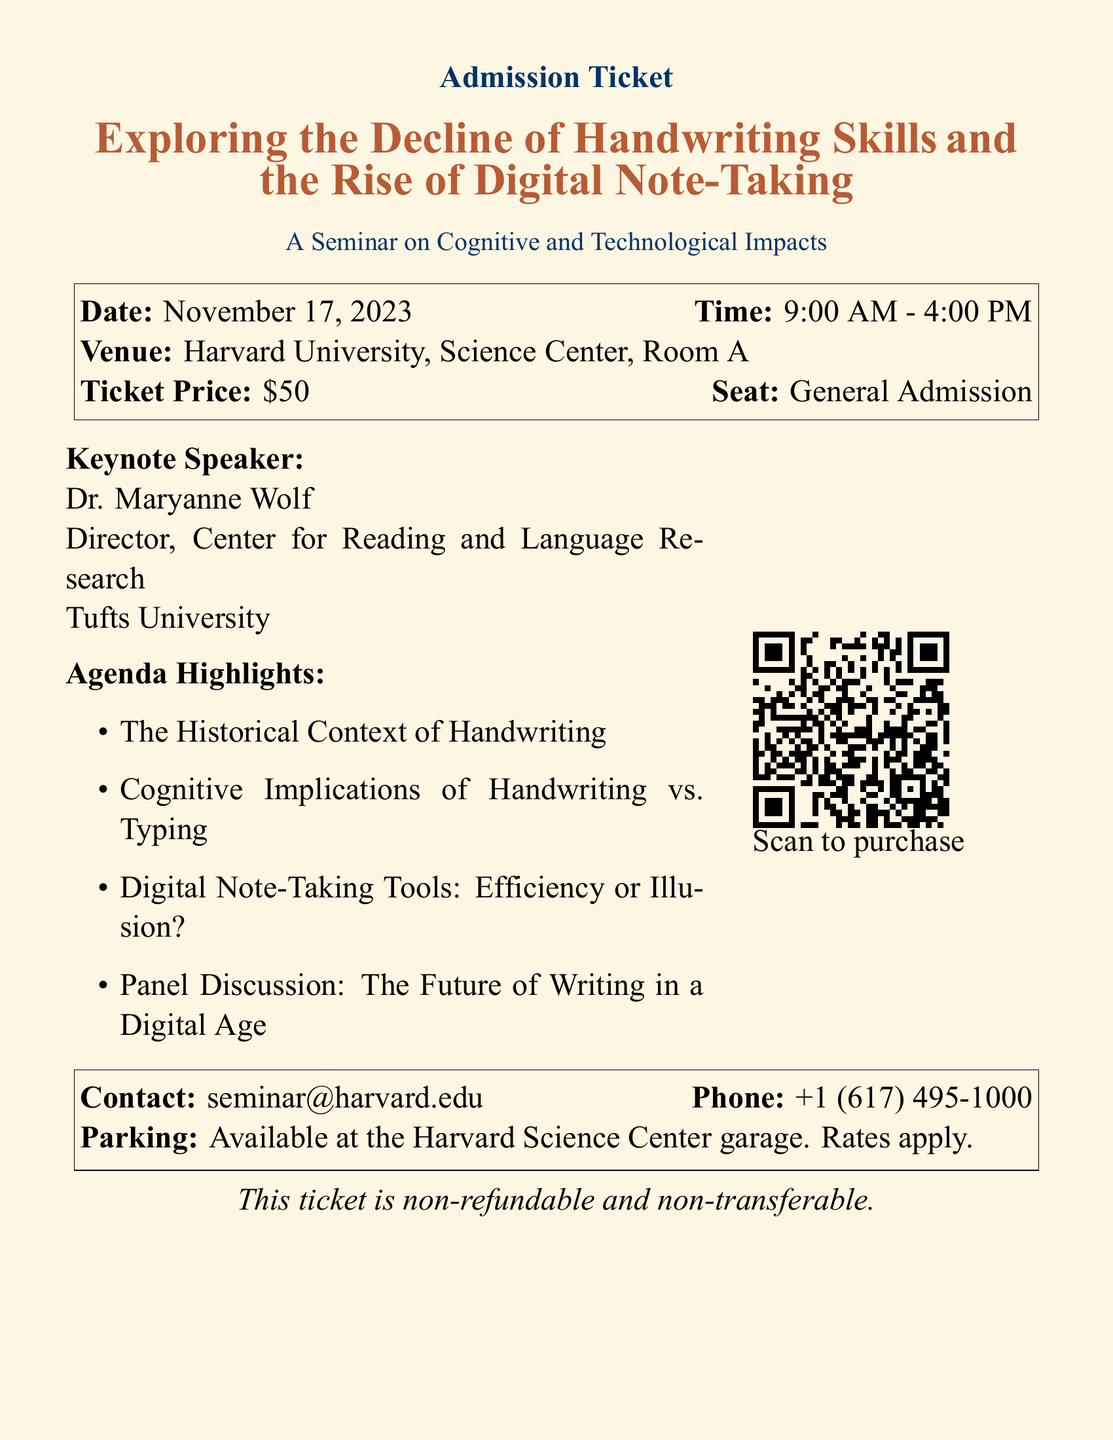What is the date of the seminar? The date of the seminar is explicitly stated in the document, which is November 17, 2023.
Answer: November 17, 2023 Who is the keynote speaker? The document lists Dr. Maryanne Wolf as the keynote speaker for the seminar.
Answer: Dr. Maryanne Wolf What is the ticket price? The ticket price for admission is mentioned in the document as $50.
Answer: $50 What time does the seminar start? The document specifies that the seminar starts at 9:00 AM.
Answer: 9:00 AM Where is the seminar being held? The venue of the seminar is provided as Harvard University, Science Center, Room A.
Answer: Harvard University, Science Center, Room A What is the topic of the panel discussion? The panel discussion's topic is indicated as "The Future of Writing in a Digital Age" in the agenda highlights.
Answer: The Future of Writing in a Digital Age What should attendees do to purchase a ticket? Attendees are directed to scan the QR code in the document to purchase a ticket.
Answer: Scan to purchase Is parking available at the venue? The document states that parking is available at the Harvard Science Center garage, noting that rates apply.
Answer: Available at the Harvard Science Center garage 